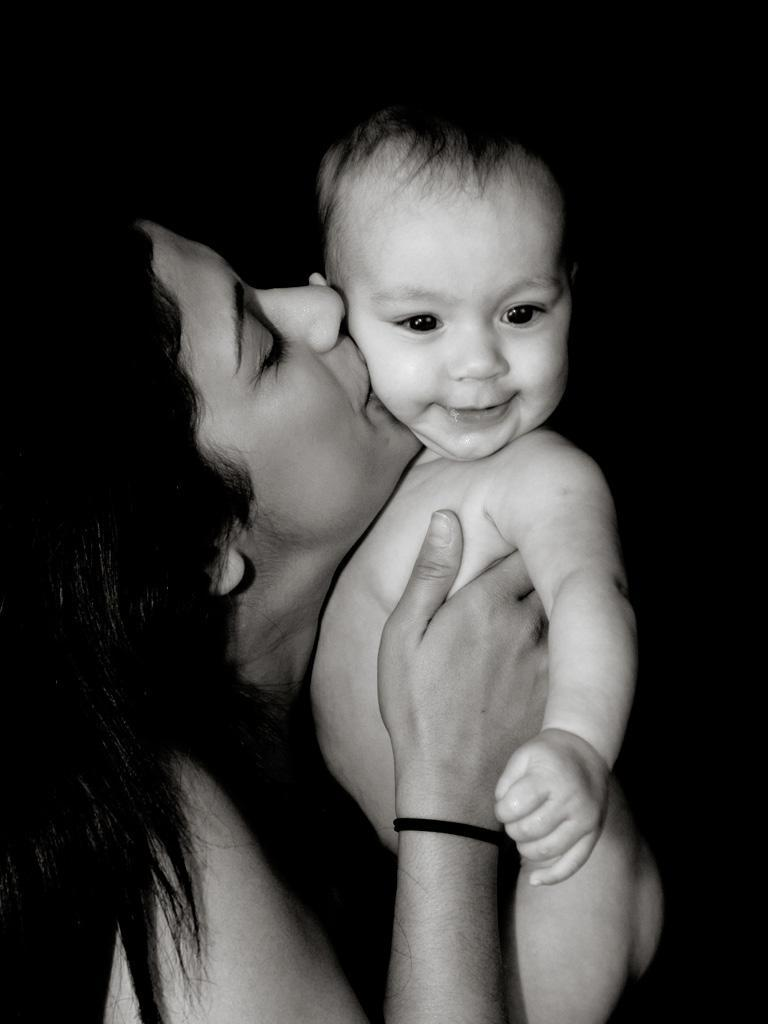What is the color scheme of the image? The image is black and white. Who is present in the image? There is a woman in the image. What is the woman doing in the image? The woman is holding a baby and kissing the baby. What is the rate at which the yak is moving in the image? There is no yak present in the image, so it is not possible to determine its movement or rate. 